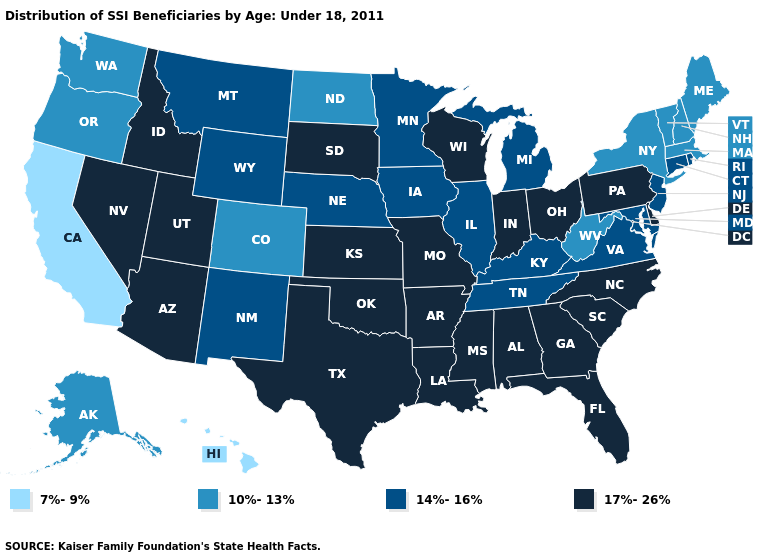Name the states that have a value in the range 17%-26%?
Quick response, please. Alabama, Arizona, Arkansas, Delaware, Florida, Georgia, Idaho, Indiana, Kansas, Louisiana, Mississippi, Missouri, Nevada, North Carolina, Ohio, Oklahoma, Pennsylvania, South Carolina, South Dakota, Texas, Utah, Wisconsin. Among the states that border South Carolina , which have the lowest value?
Quick response, please. Georgia, North Carolina. Which states have the lowest value in the USA?
Be succinct. California, Hawaii. Name the states that have a value in the range 17%-26%?
Keep it brief. Alabama, Arizona, Arkansas, Delaware, Florida, Georgia, Idaho, Indiana, Kansas, Louisiana, Mississippi, Missouri, Nevada, North Carolina, Ohio, Oklahoma, Pennsylvania, South Carolina, South Dakota, Texas, Utah, Wisconsin. Which states have the lowest value in the Northeast?
Keep it brief. Maine, Massachusetts, New Hampshire, New York, Vermont. Does Idaho have a higher value than Wisconsin?
Give a very brief answer. No. Does Massachusetts have the highest value in the Northeast?
Answer briefly. No. What is the lowest value in the West?
Be succinct. 7%-9%. What is the lowest value in the South?
Short answer required. 10%-13%. Does Maine have a higher value than Wisconsin?
Give a very brief answer. No. What is the value of Montana?
Give a very brief answer. 14%-16%. Name the states that have a value in the range 10%-13%?
Short answer required. Alaska, Colorado, Maine, Massachusetts, New Hampshire, New York, North Dakota, Oregon, Vermont, Washington, West Virginia. What is the highest value in states that border Massachusetts?
Quick response, please. 14%-16%. What is the value of South Carolina?
Concise answer only. 17%-26%. 